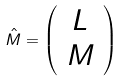<formula> <loc_0><loc_0><loc_500><loc_500>\hat { M } = \left ( \begin{array} { c } L \\ M \end{array} \right )</formula> 